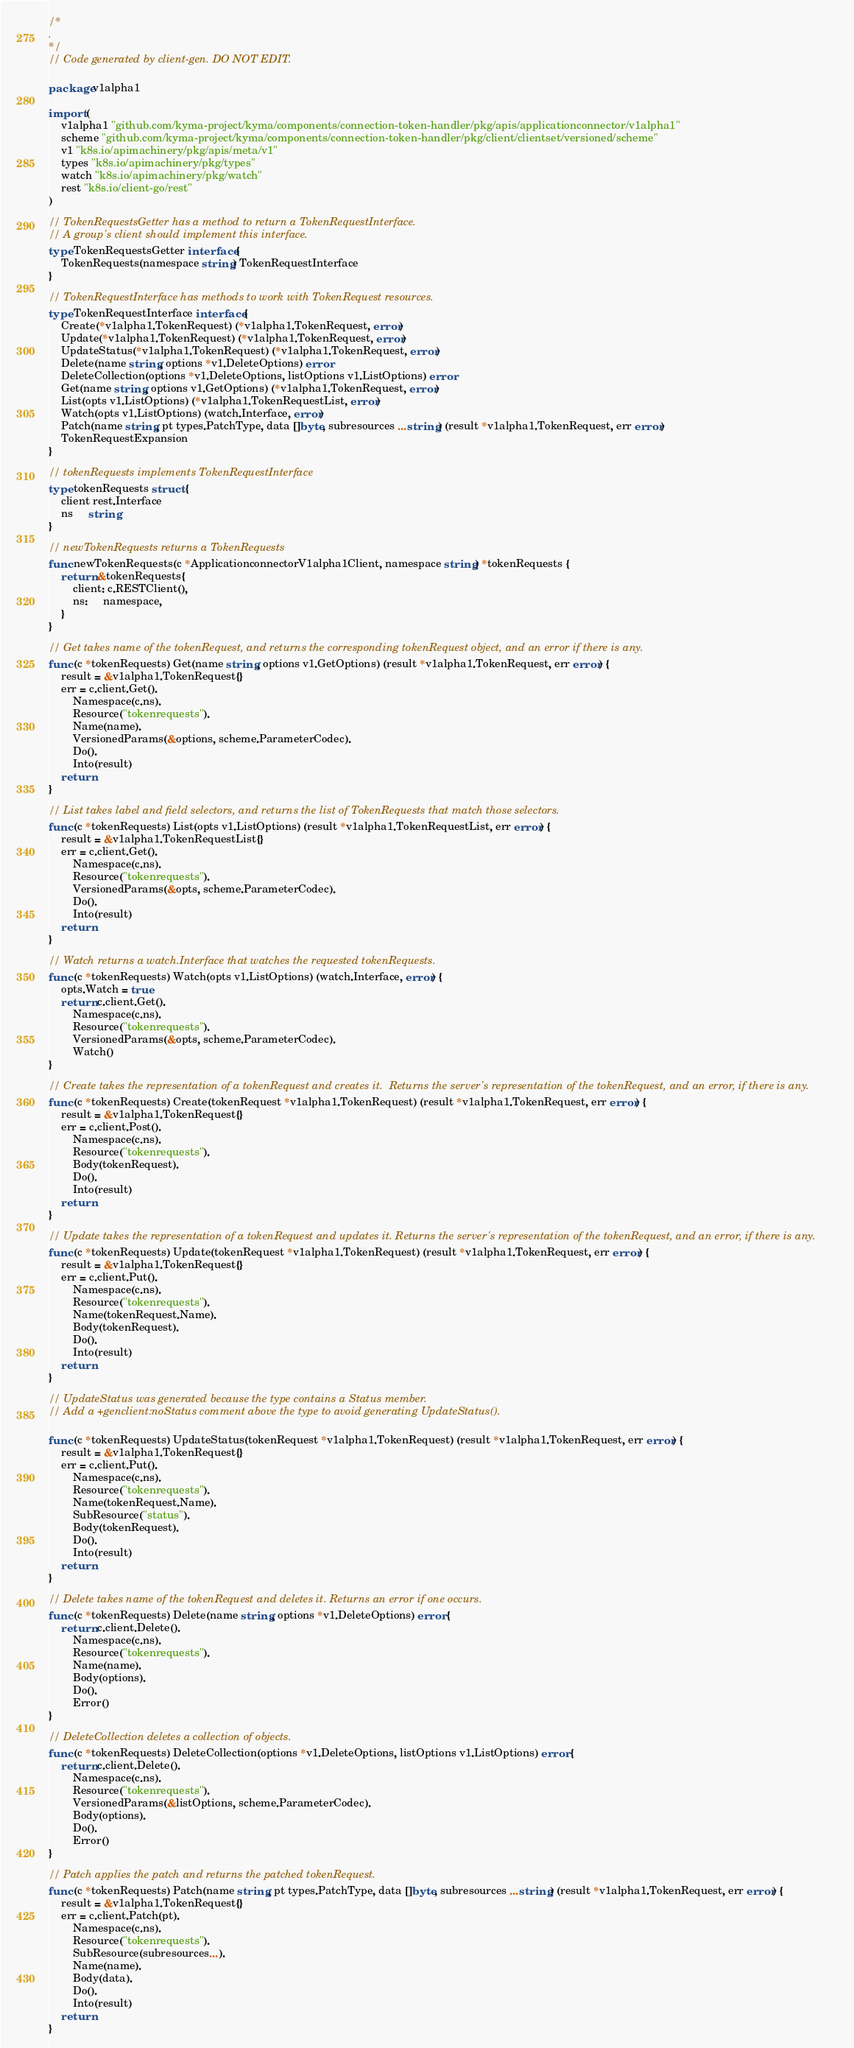Convert code to text. <code><loc_0><loc_0><loc_500><loc_500><_Go_>/*
.
*/
// Code generated by client-gen. DO NOT EDIT.

package v1alpha1

import (
	v1alpha1 "github.com/kyma-project/kyma/components/connection-token-handler/pkg/apis/applicationconnector/v1alpha1"
	scheme "github.com/kyma-project/kyma/components/connection-token-handler/pkg/client/clientset/versioned/scheme"
	v1 "k8s.io/apimachinery/pkg/apis/meta/v1"
	types "k8s.io/apimachinery/pkg/types"
	watch "k8s.io/apimachinery/pkg/watch"
	rest "k8s.io/client-go/rest"
)

// TokenRequestsGetter has a method to return a TokenRequestInterface.
// A group's client should implement this interface.
type TokenRequestsGetter interface {
	TokenRequests(namespace string) TokenRequestInterface
}

// TokenRequestInterface has methods to work with TokenRequest resources.
type TokenRequestInterface interface {
	Create(*v1alpha1.TokenRequest) (*v1alpha1.TokenRequest, error)
	Update(*v1alpha1.TokenRequest) (*v1alpha1.TokenRequest, error)
	UpdateStatus(*v1alpha1.TokenRequest) (*v1alpha1.TokenRequest, error)
	Delete(name string, options *v1.DeleteOptions) error
	DeleteCollection(options *v1.DeleteOptions, listOptions v1.ListOptions) error
	Get(name string, options v1.GetOptions) (*v1alpha1.TokenRequest, error)
	List(opts v1.ListOptions) (*v1alpha1.TokenRequestList, error)
	Watch(opts v1.ListOptions) (watch.Interface, error)
	Patch(name string, pt types.PatchType, data []byte, subresources ...string) (result *v1alpha1.TokenRequest, err error)
	TokenRequestExpansion
}

// tokenRequests implements TokenRequestInterface
type tokenRequests struct {
	client rest.Interface
	ns     string
}

// newTokenRequests returns a TokenRequests
func newTokenRequests(c *ApplicationconnectorV1alpha1Client, namespace string) *tokenRequests {
	return &tokenRequests{
		client: c.RESTClient(),
		ns:     namespace,
	}
}

// Get takes name of the tokenRequest, and returns the corresponding tokenRequest object, and an error if there is any.
func (c *tokenRequests) Get(name string, options v1.GetOptions) (result *v1alpha1.TokenRequest, err error) {
	result = &v1alpha1.TokenRequest{}
	err = c.client.Get().
		Namespace(c.ns).
		Resource("tokenrequests").
		Name(name).
		VersionedParams(&options, scheme.ParameterCodec).
		Do().
		Into(result)
	return
}

// List takes label and field selectors, and returns the list of TokenRequests that match those selectors.
func (c *tokenRequests) List(opts v1.ListOptions) (result *v1alpha1.TokenRequestList, err error) {
	result = &v1alpha1.TokenRequestList{}
	err = c.client.Get().
		Namespace(c.ns).
		Resource("tokenrequests").
		VersionedParams(&opts, scheme.ParameterCodec).
		Do().
		Into(result)
	return
}

// Watch returns a watch.Interface that watches the requested tokenRequests.
func (c *tokenRequests) Watch(opts v1.ListOptions) (watch.Interface, error) {
	opts.Watch = true
	return c.client.Get().
		Namespace(c.ns).
		Resource("tokenrequests").
		VersionedParams(&opts, scheme.ParameterCodec).
		Watch()
}

// Create takes the representation of a tokenRequest and creates it.  Returns the server's representation of the tokenRequest, and an error, if there is any.
func (c *tokenRequests) Create(tokenRequest *v1alpha1.TokenRequest) (result *v1alpha1.TokenRequest, err error) {
	result = &v1alpha1.TokenRequest{}
	err = c.client.Post().
		Namespace(c.ns).
		Resource("tokenrequests").
		Body(tokenRequest).
		Do().
		Into(result)
	return
}

// Update takes the representation of a tokenRequest and updates it. Returns the server's representation of the tokenRequest, and an error, if there is any.
func (c *tokenRequests) Update(tokenRequest *v1alpha1.TokenRequest) (result *v1alpha1.TokenRequest, err error) {
	result = &v1alpha1.TokenRequest{}
	err = c.client.Put().
		Namespace(c.ns).
		Resource("tokenrequests").
		Name(tokenRequest.Name).
		Body(tokenRequest).
		Do().
		Into(result)
	return
}

// UpdateStatus was generated because the type contains a Status member.
// Add a +genclient:noStatus comment above the type to avoid generating UpdateStatus().

func (c *tokenRequests) UpdateStatus(tokenRequest *v1alpha1.TokenRequest) (result *v1alpha1.TokenRequest, err error) {
	result = &v1alpha1.TokenRequest{}
	err = c.client.Put().
		Namespace(c.ns).
		Resource("tokenrequests").
		Name(tokenRequest.Name).
		SubResource("status").
		Body(tokenRequest).
		Do().
		Into(result)
	return
}

// Delete takes name of the tokenRequest and deletes it. Returns an error if one occurs.
func (c *tokenRequests) Delete(name string, options *v1.DeleteOptions) error {
	return c.client.Delete().
		Namespace(c.ns).
		Resource("tokenrequests").
		Name(name).
		Body(options).
		Do().
		Error()
}

// DeleteCollection deletes a collection of objects.
func (c *tokenRequests) DeleteCollection(options *v1.DeleteOptions, listOptions v1.ListOptions) error {
	return c.client.Delete().
		Namespace(c.ns).
		Resource("tokenrequests").
		VersionedParams(&listOptions, scheme.ParameterCodec).
		Body(options).
		Do().
		Error()
}

// Patch applies the patch and returns the patched tokenRequest.
func (c *tokenRequests) Patch(name string, pt types.PatchType, data []byte, subresources ...string) (result *v1alpha1.TokenRequest, err error) {
	result = &v1alpha1.TokenRequest{}
	err = c.client.Patch(pt).
		Namespace(c.ns).
		Resource("tokenrequests").
		SubResource(subresources...).
		Name(name).
		Body(data).
		Do().
		Into(result)
	return
}
</code> 